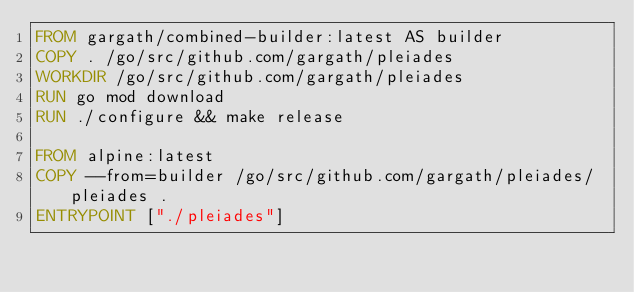Convert code to text. <code><loc_0><loc_0><loc_500><loc_500><_Dockerfile_>FROM gargath/combined-builder:latest AS builder
COPY . /go/src/github.com/gargath/pleiades
WORKDIR /go/src/github.com/gargath/pleiades
RUN go mod download
RUN ./configure && make release

FROM alpine:latest
COPY --from=builder /go/src/github.com/gargath/pleiades/pleiades .
ENTRYPOINT ["./pleiades"]
</code> 